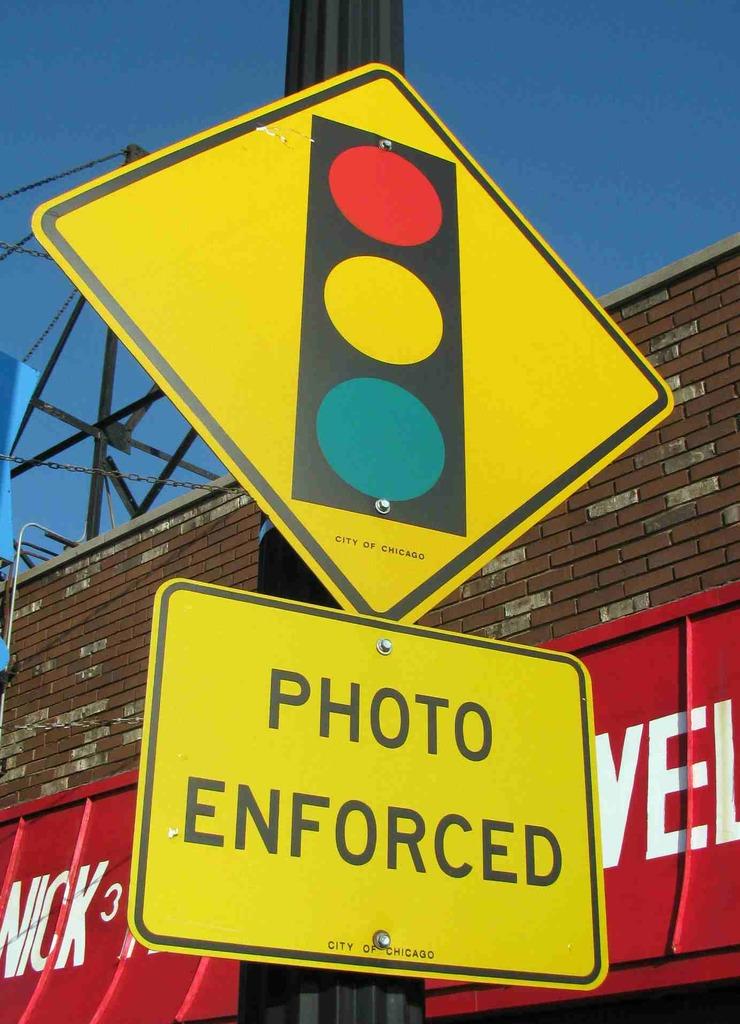What is the city this sign is in?
Provide a succinct answer. Chicago. 